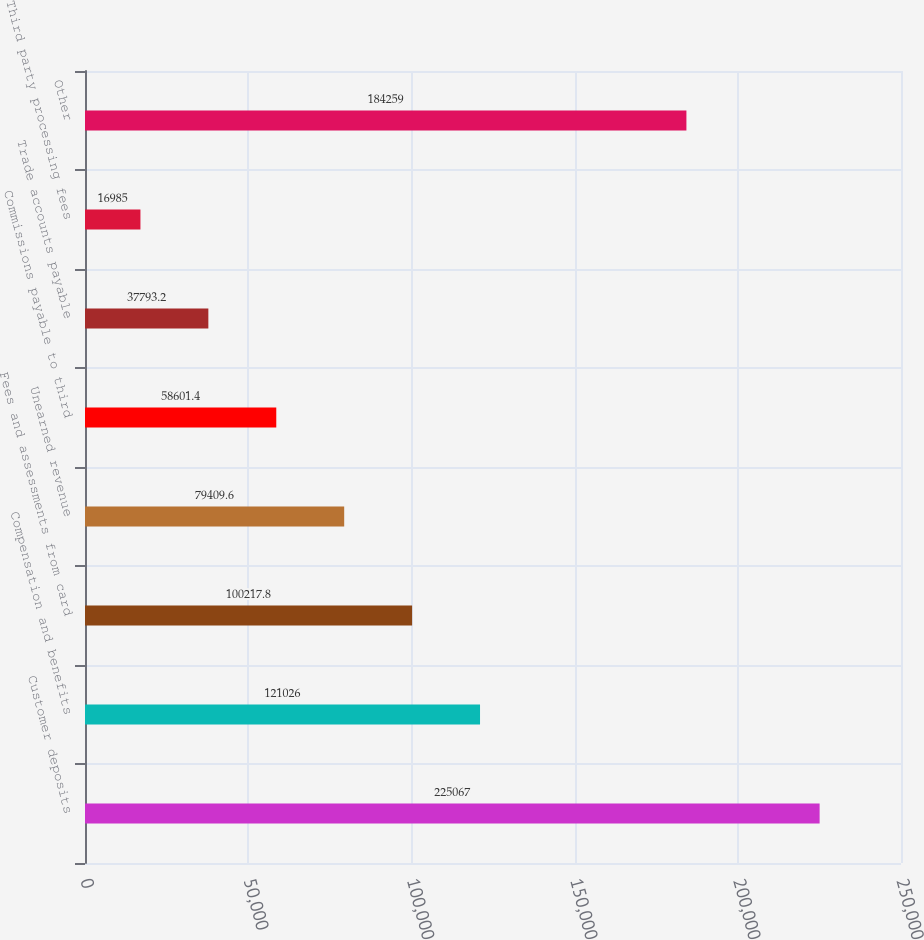<chart> <loc_0><loc_0><loc_500><loc_500><bar_chart><fcel>Customer deposits<fcel>Compensation and benefits<fcel>Fees and assessments from card<fcel>Unearned revenue<fcel>Commissions payable to third<fcel>Trade accounts payable<fcel>Third party processing fees<fcel>Other<nl><fcel>225067<fcel>121026<fcel>100218<fcel>79409.6<fcel>58601.4<fcel>37793.2<fcel>16985<fcel>184259<nl></chart> 